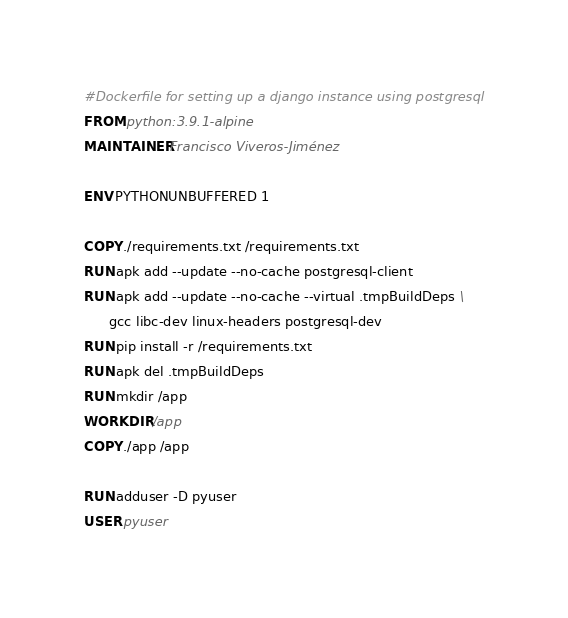Convert code to text. <code><loc_0><loc_0><loc_500><loc_500><_Dockerfile_>#Dockerfile for setting up a django instance using postgresql
FROM python:3.9.1-alpine
MAINTAINER Francisco Viveros-Jiménez

ENV PYTHONUNBUFFERED 1

COPY ./requirements.txt /requirements.txt
RUN apk add --update --no-cache postgresql-client
RUN apk add --update --no-cache --virtual .tmpBuildDeps \
      gcc libc-dev linux-headers postgresql-dev
RUN pip install -r /requirements.txt
RUN apk del .tmpBuildDeps
RUN mkdir /app
WORKDIR /app
COPY ./app /app

RUN adduser -D pyuser
USER pyuser
</code> 